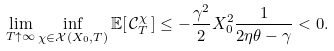Convert formula to latex. <formula><loc_0><loc_0><loc_500><loc_500>\lim _ { T \uparrow \infty } \inf _ { \chi \in \mathcal { X } ( X _ { 0 } , T ) } \mathbb { E } [ \, \mathcal { C } _ { T } ^ { \chi } \, ] \leq - \frac { \gamma ^ { 2 } } { 2 } X _ { 0 } ^ { 2 } \frac { 1 } { 2 \eta \theta - \gamma } < 0 .</formula> 